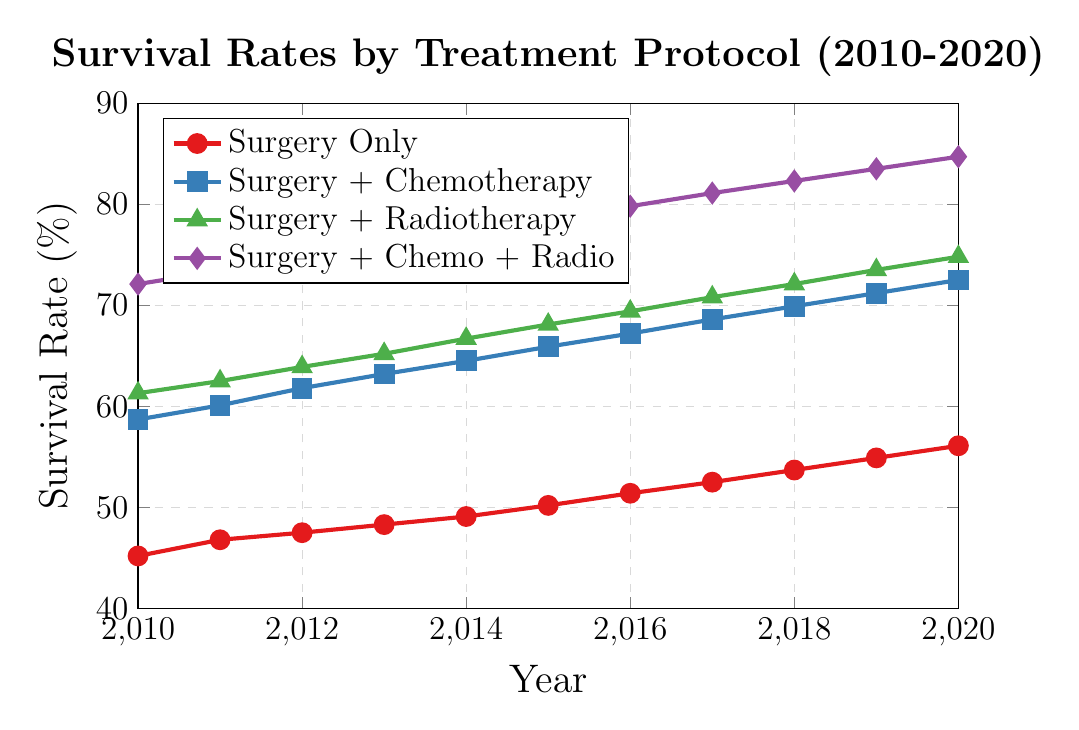What is the survival rate in 2015 for the "Surgery + Chemo + Radio" group? Check the line for "Surgery + Chemo + Radio" and identify the point corresponding to the year 2015, which has a survival rate of 78.6%.
Answer: 78.6% How much did the survival rate for "Surgery Only" increase from 2010 to 2020? Locate the survival rates for "Surgery Only" in 2010 (45.2%) and 2020 (56.1%). The increase is 56.1% - 45.2% = 10.9%.
Answer: 10.9% Which treatment group had the highest survival rate in 2020, and what was the rate? Examine the survival rates in 2020 and identify that "Surgery + Chemo + Radio" had the highest rate at 84.7%.
Answer: Surgery + Chemo + Radio (84.7%) Compare the survival rate trends between "Surgery + Chemotherapy" and "Surgery + Radiotherapy" from 2010 to 2020. Which group had a higher increase? Both trends are increasing; calculate the increase for "Surgery + Chemotherapy" (72.5% - 58.7% = 13.8%) and "Surgery + Radiotherapy" (74.8% - 61.3% = 13.5%). "Surgery + Chemotherapy" increased more by 13.8% vs 13.5%.
Answer: Surgery + Chemotherapy What was the average survival rate for the "Surgery Only" group over the decade? Sum the survival rates for "Surgery Only" (45.2, 46.8, 47.5, 48.3, 49.1, 50.2, 51.4, 52.5, 53.7, 54.9, 56.1), then divide by 11 years. Total sum: 555.7, Average: 555.7 / 11 ≈ 50.5%.
Answer: 50.5% In which year did the "Surgery + Chemotherapy" group surpass a survival rate of 70%? Identify the year where "Surgery + Chemotherapy" first exceeds 70%, which is 2019.
Answer: 2019 What is the difference in survival rate between the "Surgery + Chemo + Radio" group and the "Surgery Only" group in 2017? Identify the 2017 rates for "Surgery + Chemo + Radio" (81.1%) and "Surgery Only" (52.5%), then compute the difference: 81.1% - 52.5% = 28.6%.
Answer: 28.6% What color represents the "Surgery + Radiotherapy" group in the chart? The "Surgery + Radiotherapy" group is denoted by a green line with triangle markers, as indicated in the legend.
Answer: Green Which treatment group's survival rate trend shows the steepest average yearly increase from 2010 to 2020? Calculate the average yearly increase for each group by taking the overall increase and dividing by the 10-year span: 
- Surgery Only: (56.1 - 45.2) / 10 = 1.09
- Surgery + Chemo: (72.5 - 58.7) / 10 = 1.38
- Surgery + Radio: (74.8 - 61.3) / 10 = 1.35
- Surgery + Chemo + Radio: (84.7 - 72.1) / 10 = 1.26
The steepest average yearly increase is for "Surgery + Chemo".
Answer: Surgery + Chemo 